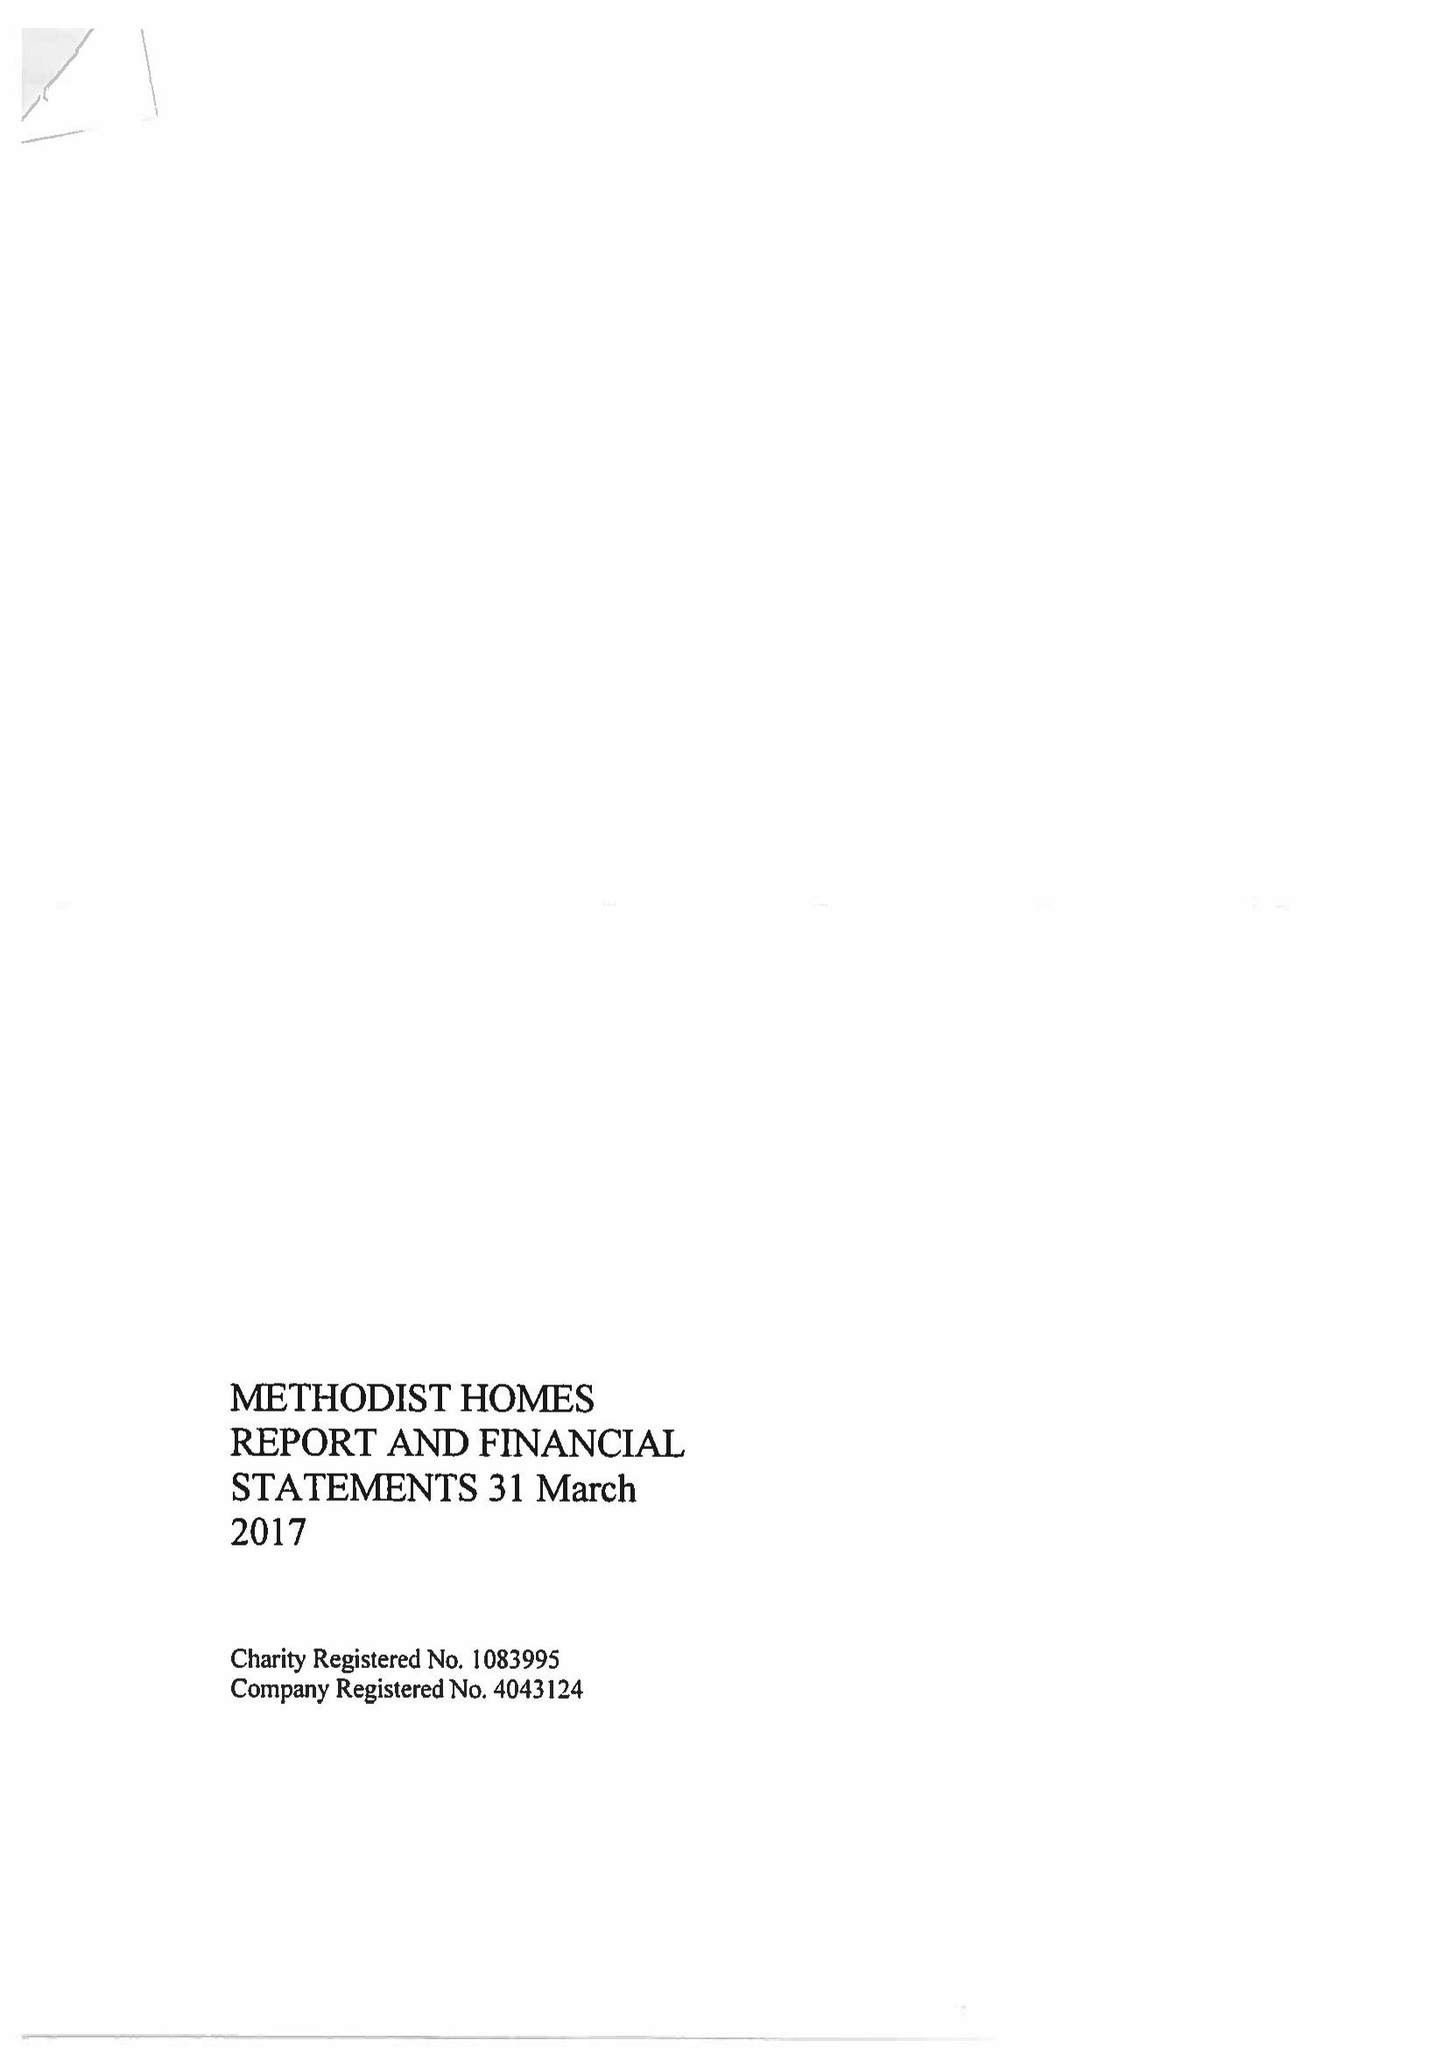What is the value for the address__post_town?
Answer the question using a single word or phrase. DERBY 